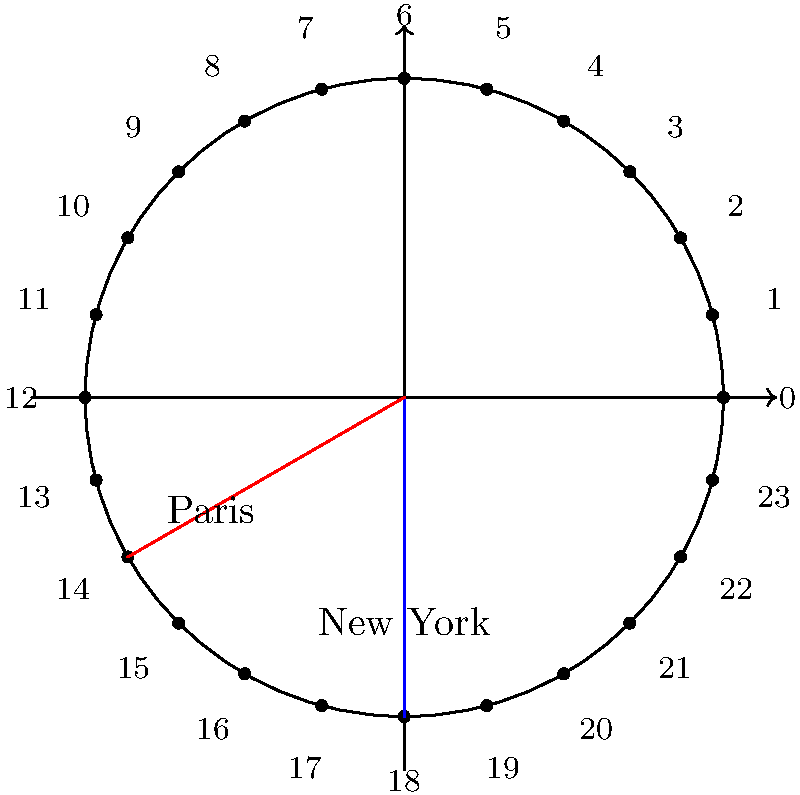You're planning your first international trip from New York to Paris. The polar clock representation shows the time zones for both cities. If it's 12 PM (noon) in New York, what time is it in Paris? Let's approach this step-by-step:

1. In the polar clock representation, each hour is represented by 15 degrees (360° / 24 hours = 15° per hour).

2. New York is represented by the blue line, which points to 12 on the clock (straight up).

3. Paris is represented by the red line, which is 5 hours ahead of New York.

4. To find the time in Paris, we need to move 5 hours clockwise from 12:
   12 PM + 5 hours = 5 PM

5. We can verify this on the polar clock:
   - Start at 12 (New York time)
   - Move 5 steps clockwise
   - We arrive at 5, which corresponds to 5 PM in Paris

Therefore, when it's 12 PM (noon) in New York, it's 5 PM in Paris.
Answer: 5 PM 